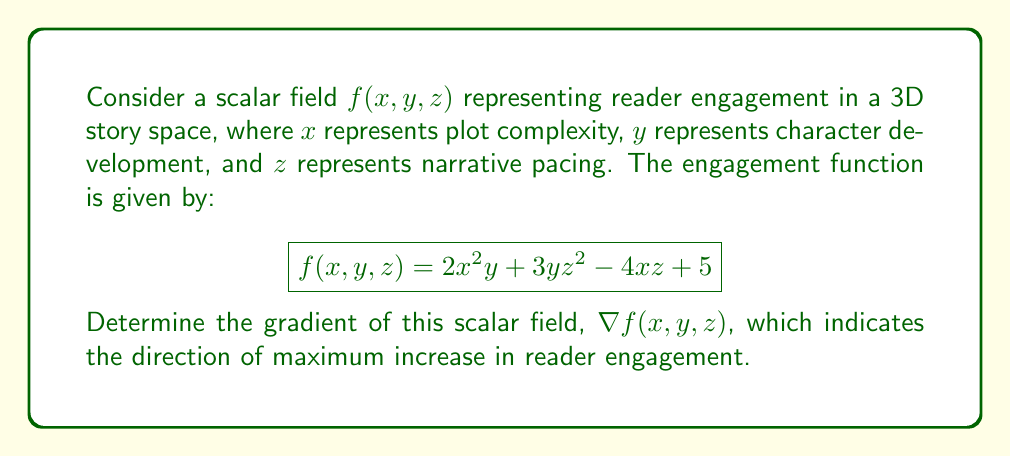Show me your answer to this math problem. To find the gradient of the scalar field $f(x, y, z)$, we need to calculate the partial derivatives with respect to each variable:

1. Calculate $\frac{\partial f}{\partial x}$:
   $$\frac{\partial f}{\partial x} = \frac{\partial}{\partial x}(2x^2y + 3yz^2 - 4xz + 5) = 4xy - 4z$$

2. Calculate $\frac{\partial f}{\partial y}$:
   $$\frac{\partial f}{\partial y} = \frac{\partial}{\partial y}(2x^2y + 3yz^2 - 4xz + 5) = 2x^2 + 3z^2$$

3. Calculate $\frac{\partial f}{\partial z}$:
   $$\frac{\partial f}{\partial z} = \frac{\partial}{\partial z}(2x^2y + 3yz^2 - 4xz + 5) = 6yz - 4x$$

4. Combine the partial derivatives to form the gradient:
   $$\nabla f(x, y, z) = \left(\frac{\partial f}{\partial x}, \frac{\partial f}{\partial y}, \frac{\partial f}{\partial z}\right)$$

Therefore, the gradient of the scalar field is:
$$\nabla f(x, y, z) = (4xy - 4z, 2x^2 + 3z^2, 6yz - 4x)$$
Answer: $$\nabla f(x, y, z) = (4xy - 4z, 2x^2 + 3z^2, 6yz - 4x)$$ 